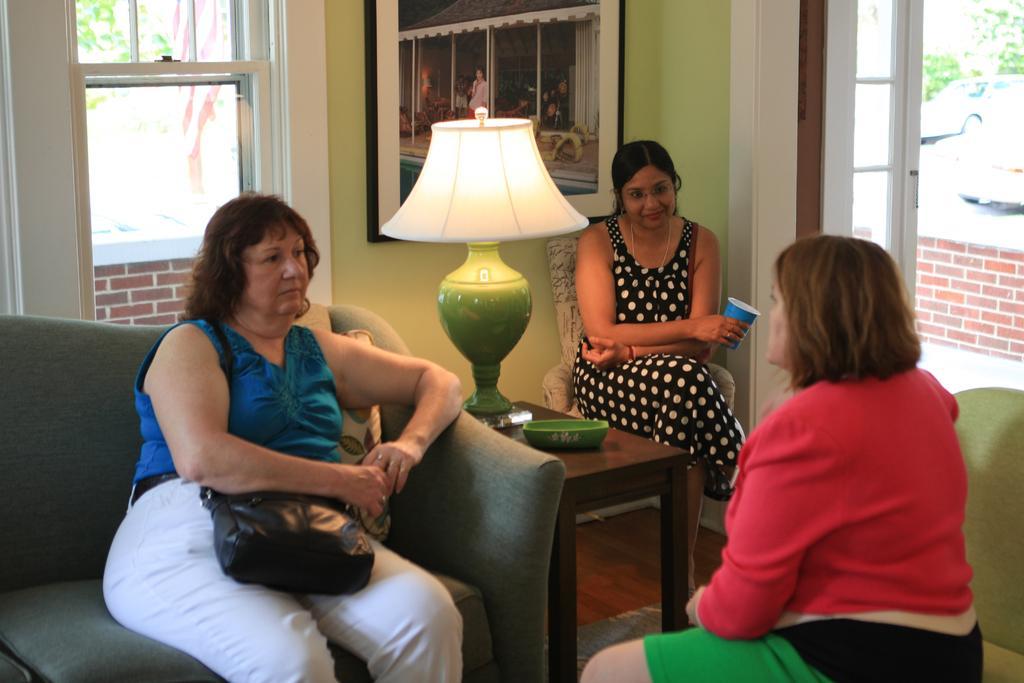Can you describe this image briefly? In this picture we can see three woman sitting on chair and here woman sitting on sofa keeping bag with her and in front of them there is table and on table we can see bowl, lamp and in background we can see window, wall with frame. 